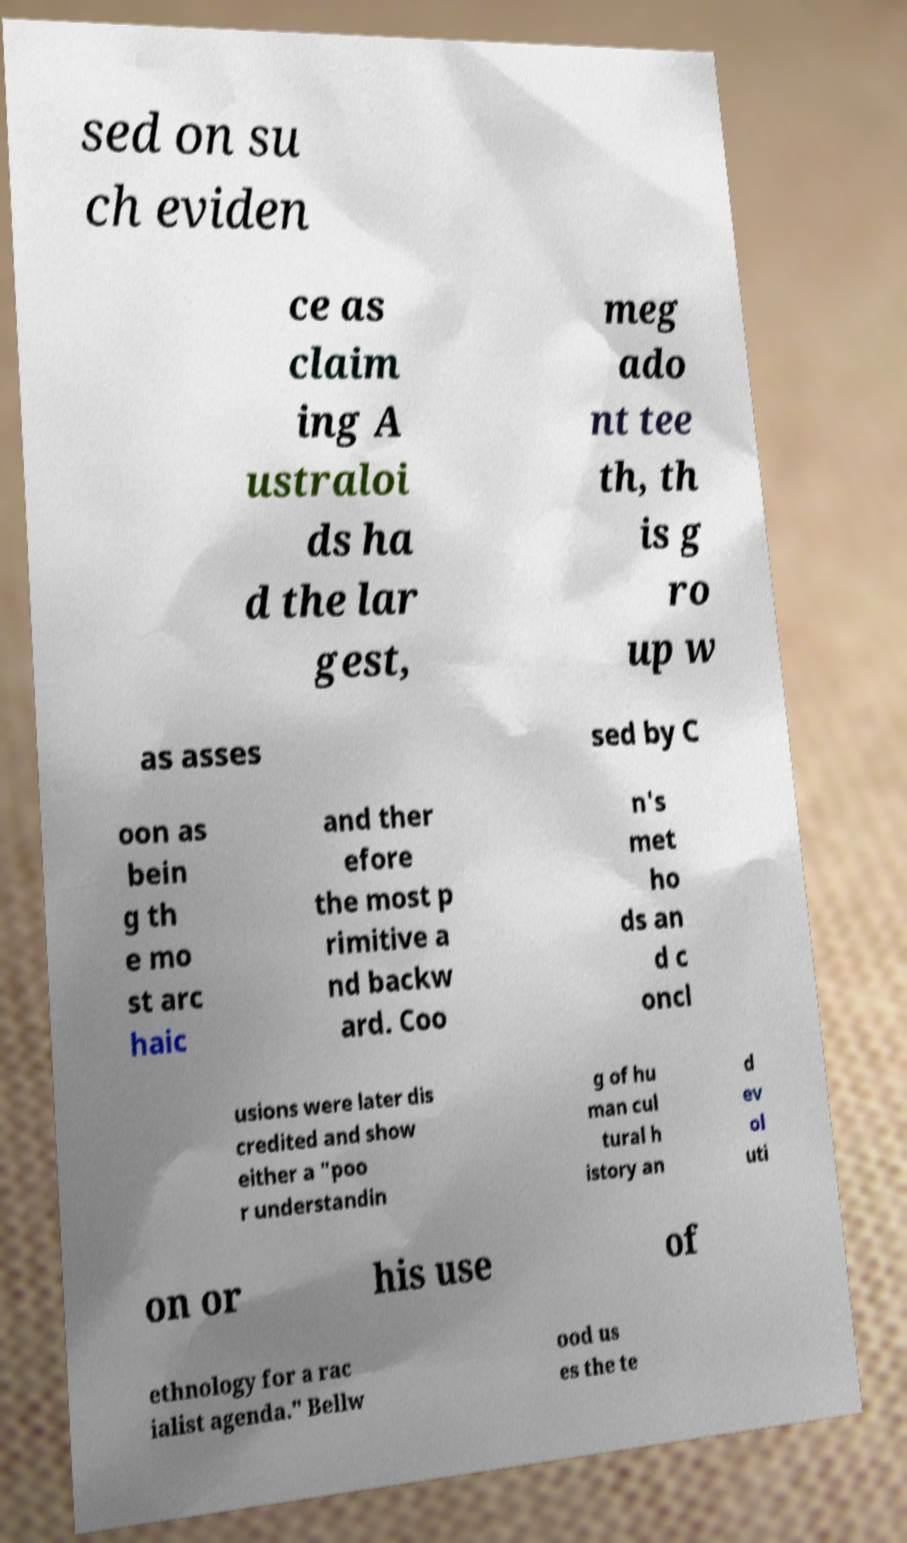Can you accurately transcribe the text from the provided image for me? sed on su ch eviden ce as claim ing A ustraloi ds ha d the lar gest, meg ado nt tee th, th is g ro up w as asses sed by C oon as bein g th e mo st arc haic and ther efore the most p rimitive a nd backw ard. Coo n's met ho ds an d c oncl usions were later dis credited and show either a "poo r understandin g of hu man cul tural h istory an d ev ol uti on or his use of ethnology for a rac ialist agenda." Bellw ood us es the te 